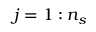<formula> <loc_0><loc_0><loc_500><loc_500>j = 1 \colon n _ { s }</formula> 